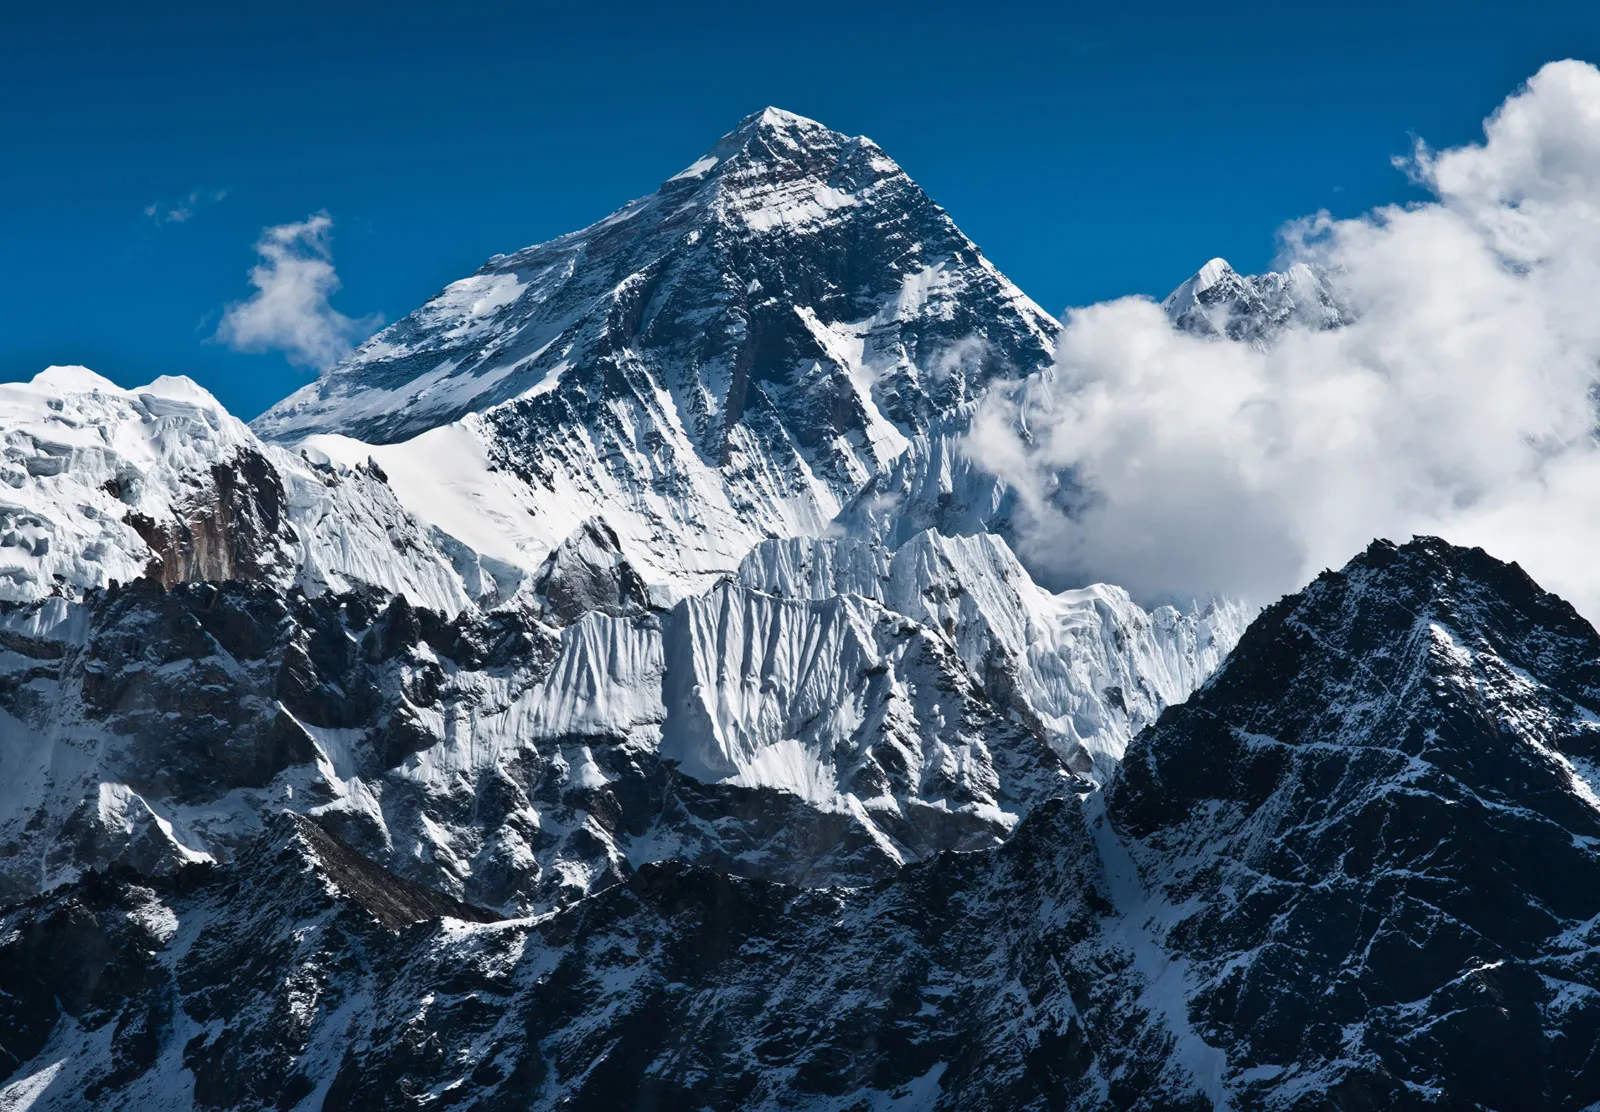What emotions do you think this image of Mount Everest evokes? This image of Mount Everest likely evokes a sense of awe and wonder, given its towering height and majestic presence. The pristine snow and rugged terrain might also inspire feelings of serenity and respect for nature's raw beauty. Additionally, the remoteness and untouched quality of the landscape could elicit emotions of solitude and reflection. 